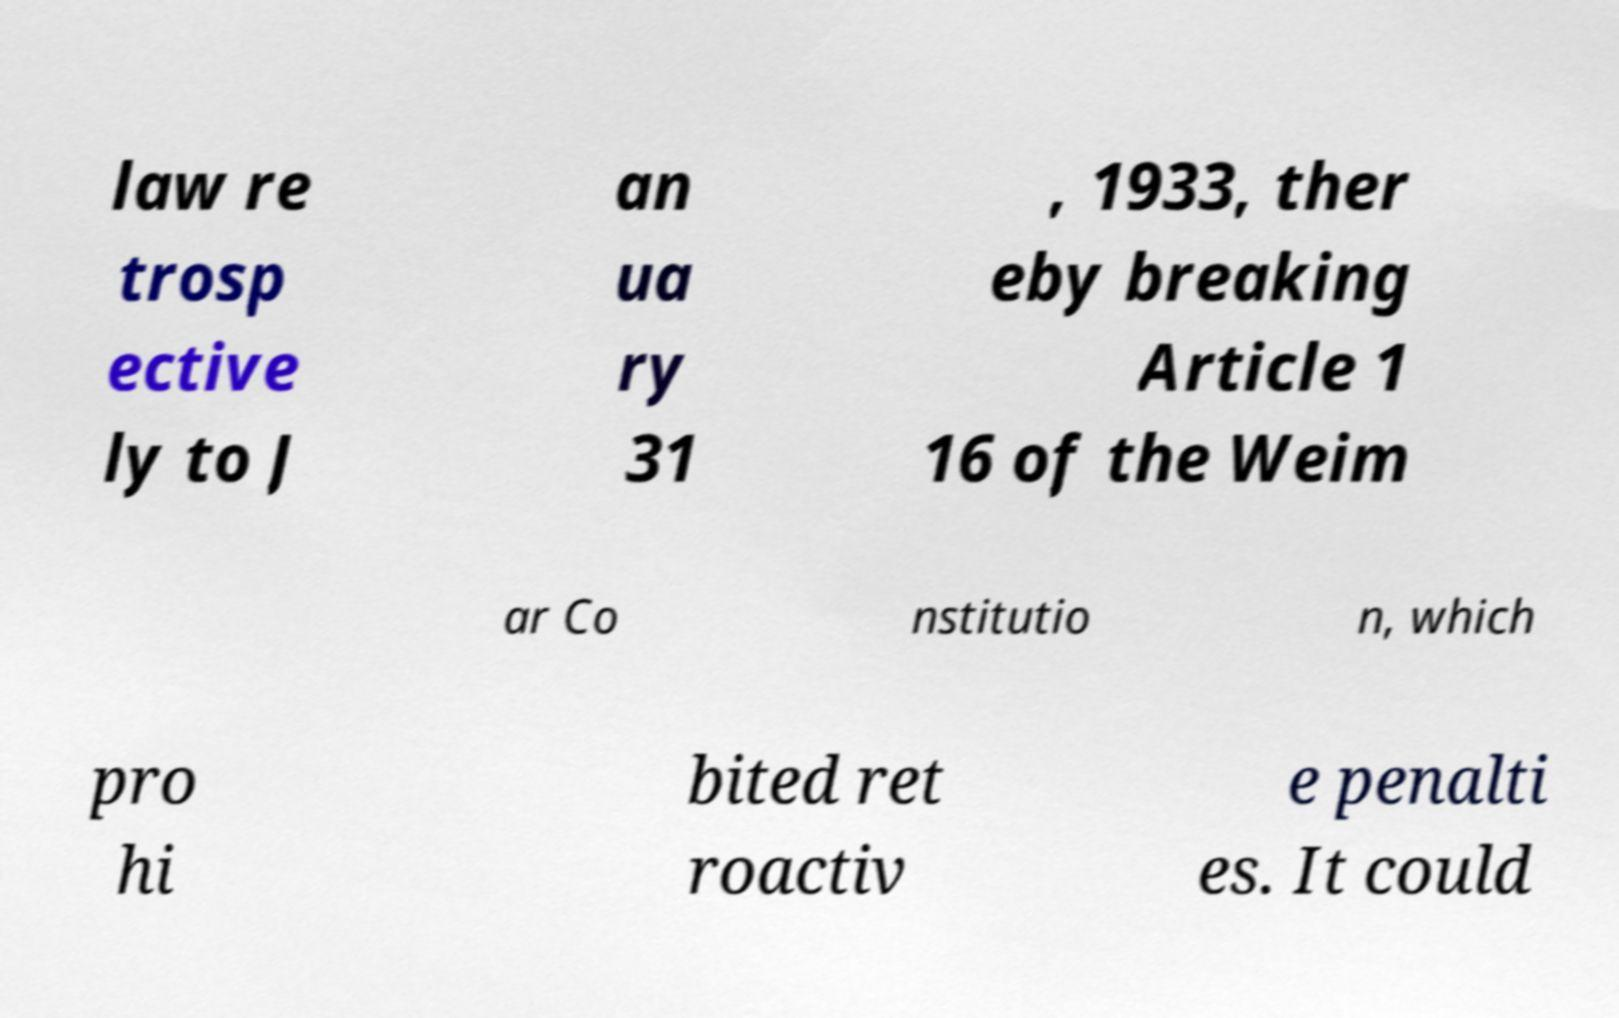There's text embedded in this image that I need extracted. Can you transcribe it verbatim? law re trosp ective ly to J an ua ry 31 , 1933, ther eby breaking Article 1 16 of the Weim ar Co nstitutio n, which pro hi bited ret roactiv e penalti es. It could 